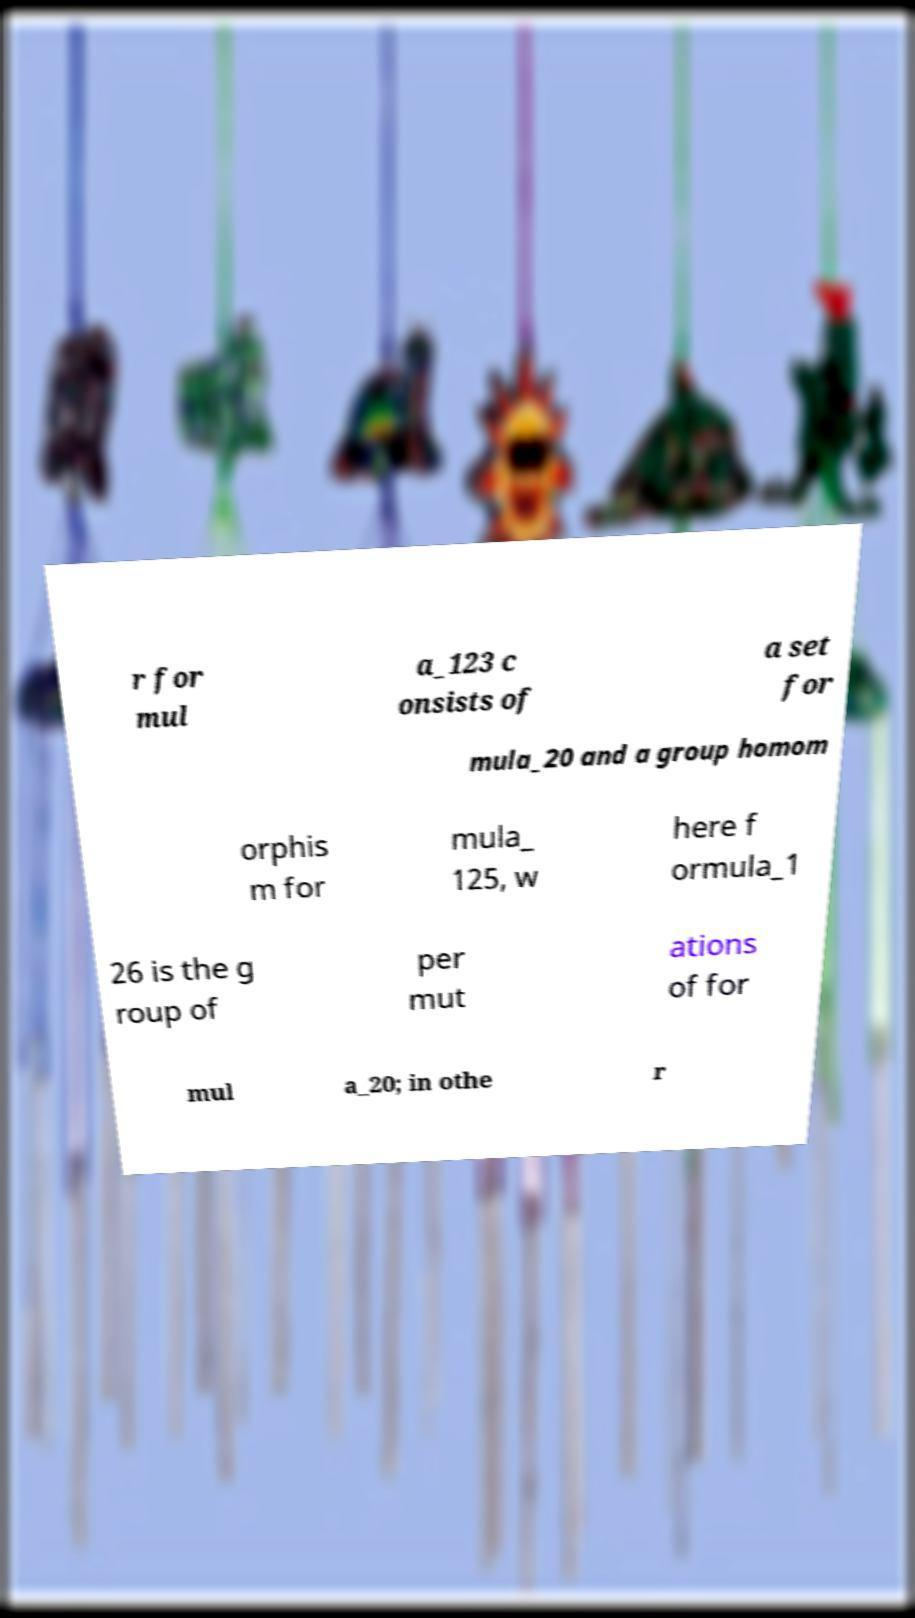Could you assist in decoding the text presented in this image and type it out clearly? r for mul a_123 c onsists of a set for mula_20 and a group homom orphis m for mula_ 125, w here f ormula_1 26 is the g roup of per mut ations of for mul a_20; in othe r 